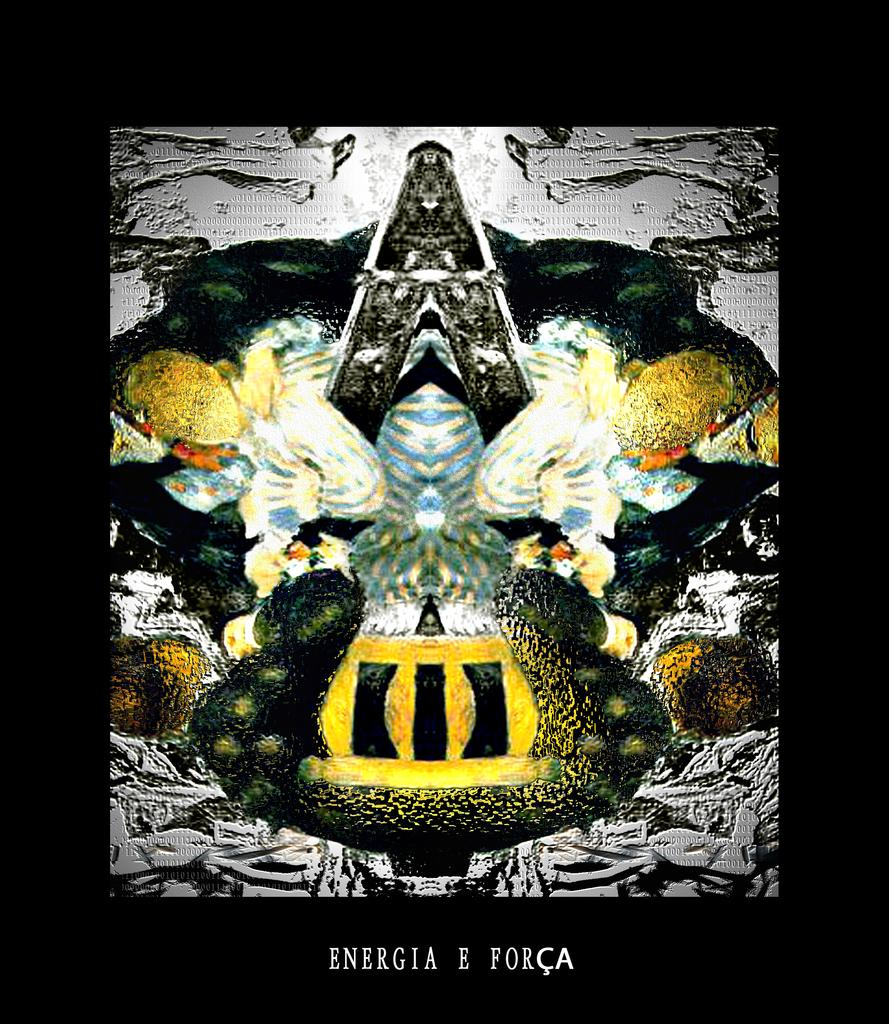What is the color of the borders surrounding the image? The image has black borders. What can be found in the center of the image? There is an object in the center of the image. Where is the text located in the image? The text is at the bottom of the image. Is there a woman whispering quietly in the lettuce in the image? There is no woman or lettuce present in the image. 